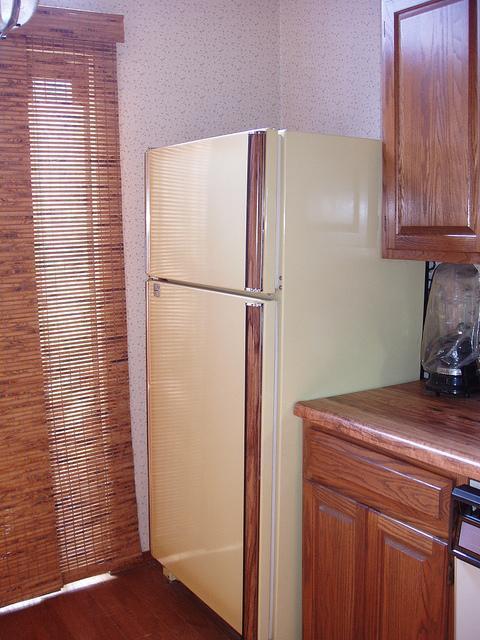How many ovens can you see?
Give a very brief answer. 1. 